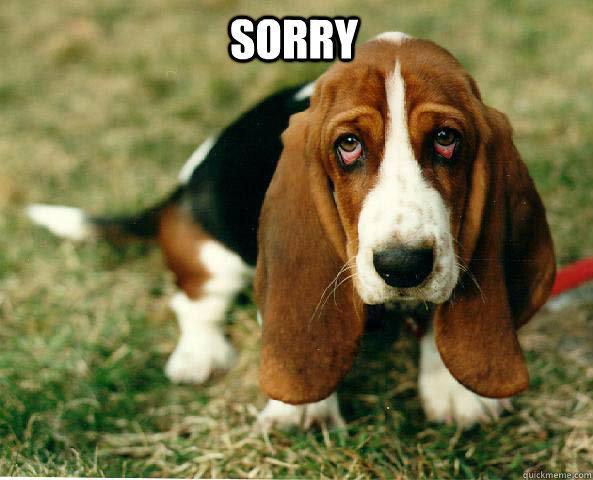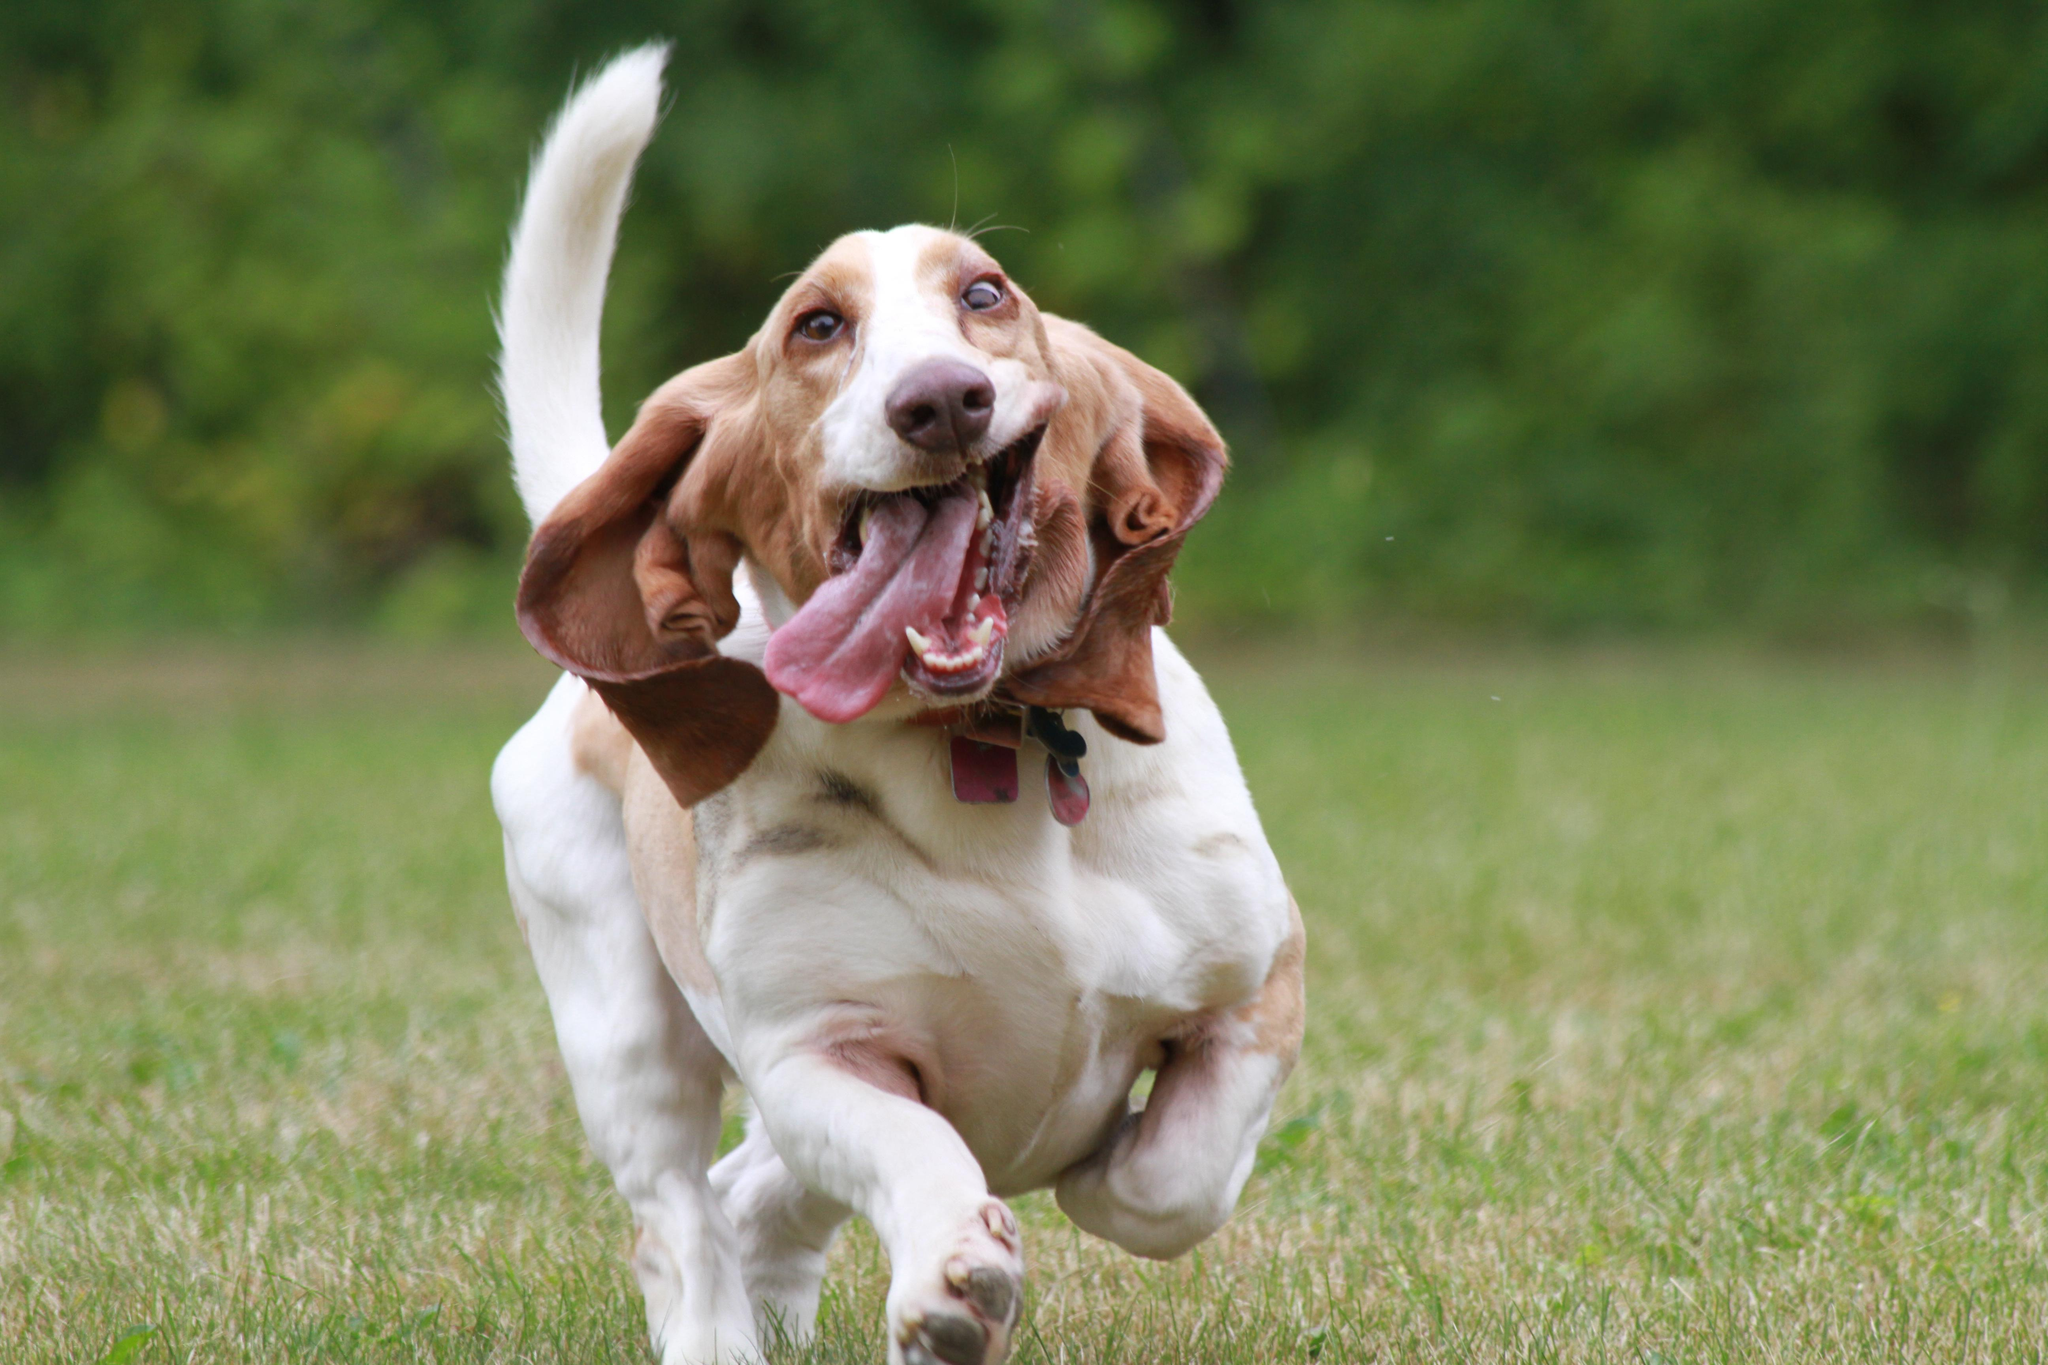The first image is the image on the left, the second image is the image on the right. Analyze the images presented: Is the assertion "The dog in one of the images is running toward the camera." valid? Answer yes or no. Yes. 